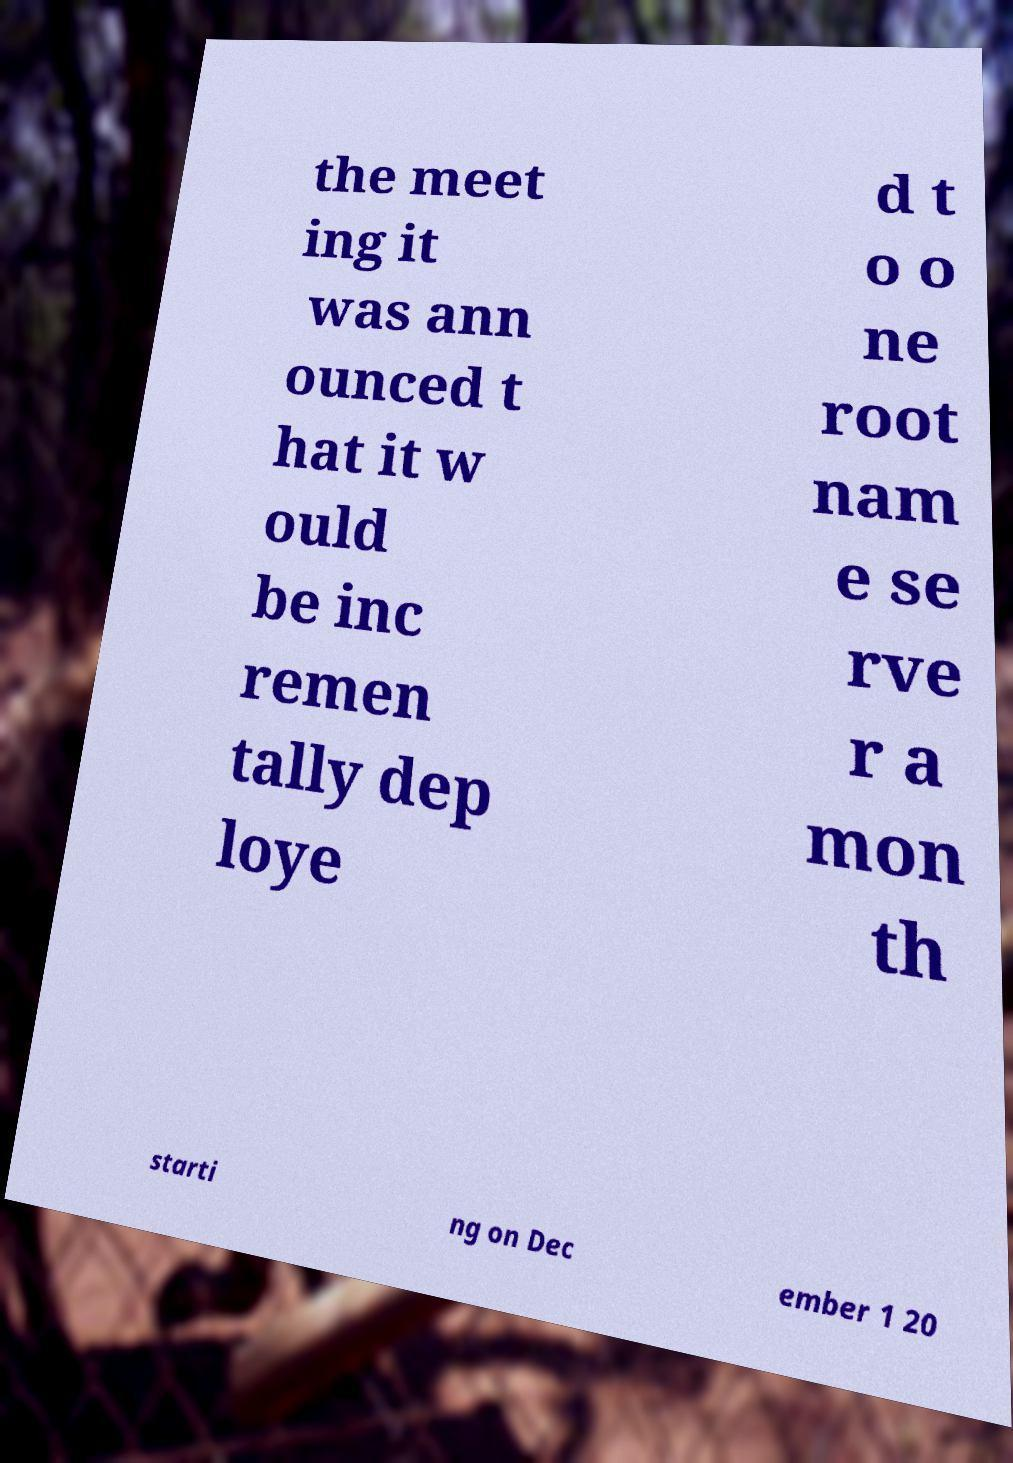Could you assist in decoding the text presented in this image and type it out clearly? the meet ing it was ann ounced t hat it w ould be inc remen tally dep loye d t o o ne root nam e se rve r a mon th starti ng on Dec ember 1 20 